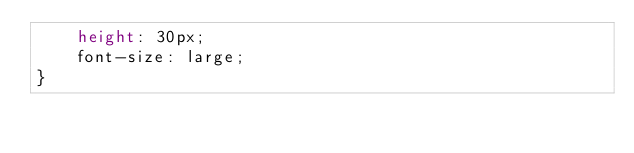Convert code to text. <code><loc_0><loc_0><loc_500><loc_500><_CSS_>    height: 30px;
    font-size: large;
}</code> 